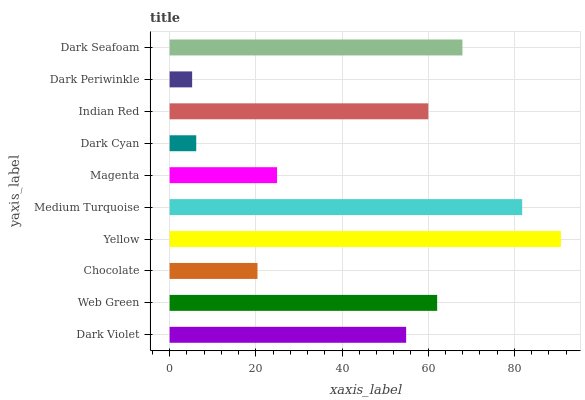Is Dark Periwinkle the minimum?
Answer yes or no. Yes. Is Yellow the maximum?
Answer yes or no. Yes. Is Web Green the minimum?
Answer yes or no. No. Is Web Green the maximum?
Answer yes or no. No. Is Web Green greater than Dark Violet?
Answer yes or no. Yes. Is Dark Violet less than Web Green?
Answer yes or no. Yes. Is Dark Violet greater than Web Green?
Answer yes or no. No. Is Web Green less than Dark Violet?
Answer yes or no. No. Is Indian Red the high median?
Answer yes or no. Yes. Is Dark Violet the low median?
Answer yes or no. Yes. Is Dark Cyan the high median?
Answer yes or no. No. Is Dark Seafoam the low median?
Answer yes or no. No. 